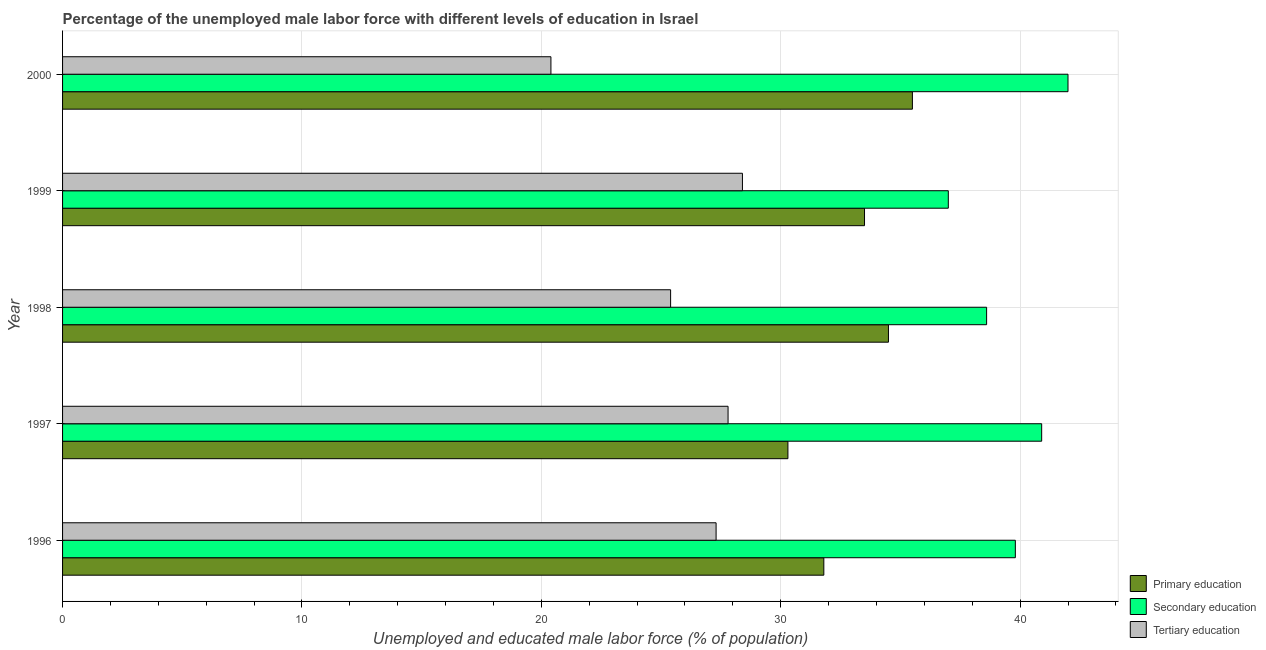How many different coloured bars are there?
Give a very brief answer. 3. Are the number of bars per tick equal to the number of legend labels?
Ensure brevity in your answer.  Yes. Are the number of bars on each tick of the Y-axis equal?
Your answer should be compact. Yes. What is the label of the 1st group of bars from the top?
Make the answer very short. 2000. What is the percentage of male labor force who received secondary education in 1999?
Make the answer very short. 37. Across all years, what is the maximum percentage of male labor force who received primary education?
Offer a terse response. 35.5. In which year was the percentage of male labor force who received secondary education maximum?
Give a very brief answer. 2000. In which year was the percentage of male labor force who received primary education minimum?
Your response must be concise. 1997. What is the total percentage of male labor force who received primary education in the graph?
Ensure brevity in your answer.  165.6. What is the difference between the percentage of male labor force who received primary education in 1998 and that in 1999?
Provide a short and direct response. 1. What is the difference between the percentage of male labor force who received primary education in 1997 and the percentage of male labor force who received tertiary education in 1999?
Offer a very short reply. 1.9. What is the average percentage of male labor force who received primary education per year?
Your answer should be very brief. 33.12. In how many years, is the percentage of male labor force who received secondary education greater than 8 %?
Give a very brief answer. 5. What is the ratio of the percentage of male labor force who received tertiary education in 1997 to that in 1998?
Your response must be concise. 1.09. Is the difference between the percentage of male labor force who received primary education in 1996 and 1998 greater than the difference between the percentage of male labor force who received tertiary education in 1996 and 1998?
Your answer should be compact. No. In how many years, is the percentage of male labor force who received secondary education greater than the average percentage of male labor force who received secondary education taken over all years?
Offer a terse response. 3. Is the sum of the percentage of male labor force who received secondary education in 1997 and 2000 greater than the maximum percentage of male labor force who received tertiary education across all years?
Provide a short and direct response. Yes. What does the 1st bar from the top in 1996 represents?
Provide a succinct answer. Tertiary education. What does the 3rd bar from the bottom in 1996 represents?
Offer a terse response. Tertiary education. Are all the bars in the graph horizontal?
Keep it short and to the point. Yes. How many years are there in the graph?
Your response must be concise. 5. Does the graph contain grids?
Your response must be concise. Yes. What is the title of the graph?
Provide a short and direct response. Percentage of the unemployed male labor force with different levels of education in Israel. Does "Capital account" appear as one of the legend labels in the graph?
Provide a succinct answer. No. What is the label or title of the X-axis?
Provide a short and direct response. Unemployed and educated male labor force (% of population). What is the label or title of the Y-axis?
Ensure brevity in your answer.  Year. What is the Unemployed and educated male labor force (% of population) of Primary education in 1996?
Make the answer very short. 31.8. What is the Unemployed and educated male labor force (% of population) of Secondary education in 1996?
Provide a succinct answer. 39.8. What is the Unemployed and educated male labor force (% of population) of Tertiary education in 1996?
Make the answer very short. 27.3. What is the Unemployed and educated male labor force (% of population) in Primary education in 1997?
Make the answer very short. 30.3. What is the Unemployed and educated male labor force (% of population) in Secondary education in 1997?
Make the answer very short. 40.9. What is the Unemployed and educated male labor force (% of population) in Tertiary education in 1997?
Provide a succinct answer. 27.8. What is the Unemployed and educated male labor force (% of population) of Primary education in 1998?
Provide a short and direct response. 34.5. What is the Unemployed and educated male labor force (% of population) of Secondary education in 1998?
Your answer should be compact. 38.6. What is the Unemployed and educated male labor force (% of population) in Tertiary education in 1998?
Your response must be concise. 25.4. What is the Unemployed and educated male labor force (% of population) in Primary education in 1999?
Offer a terse response. 33.5. What is the Unemployed and educated male labor force (% of population) in Tertiary education in 1999?
Provide a succinct answer. 28.4. What is the Unemployed and educated male labor force (% of population) in Primary education in 2000?
Make the answer very short. 35.5. What is the Unemployed and educated male labor force (% of population) of Tertiary education in 2000?
Provide a succinct answer. 20.4. Across all years, what is the maximum Unemployed and educated male labor force (% of population) of Primary education?
Give a very brief answer. 35.5. Across all years, what is the maximum Unemployed and educated male labor force (% of population) of Secondary education?
Provide a succinct answer. 42. Across all years, what is the maximum Unemployed and educated male labor force (% of population) in Tertiary education?
Offer a terse response. 28.4. Across all years, what is the minimum Unemployed and educated male labor force (% of population) in Primary education?
Give a very brief answer. 30.3. Across all years, what is the minimum Unemployed and educated male labor force (% of population) of Secondary education?
Offer a terse response. 37. Across all years, what is the minimum Unemployed and educated male labor force (% of population) in Tertiary education?
Provide a succinct answer. 20.4. What is the total Unemployed and educated male labor force (% of population) in Primary education in the graph?
Your answer should be very brief. 165.6. What is the total Unemployed and educated male labor force (% of population) of Secondary education in the graph?
Your answer should be very brief. 198.3. What is the total Unemployed and educated male labor force (% of population) in Tertiary education in the graph?
Provide a succinct answer. 129.3. What is the difference between the Unemployed and educated male labor force (% of population) in Tertiary education in 1996 and that in 1997?
Offer a terse response. -0.5. What is the difference between the Unemployed and educated male labor force (% of population) in Primary education in 1996 and that in 1998?
Your answer should be compact. -2.7. What is the difference between the Unemployed and educated male labor force (% of population) in Secondary education in 1996 and that in 1998?
Offer a very short reply. 1.2. What is the difference between the Unemployed and educated male labor force (% of population) of Primary education in 1996 and that in 1999?
Your response must be concise. -1.7. What is the difference between the Unemployed and educated male labor force (% of population) in Primary education in 1996 and that in 2000?
Ensure brevity in your answer.  -3.7. What is the difference between the Unemployed and educated male labor force (% of population) in Tertiary education in 1996 and that in 2000?
Provide a succinct answer. 6.9. What is the difference between the Unemployed and educated male labor force (% of population) in Primary education in 1997 and that in 1998?
Keep it short and to the point. -4.2. What is the difference between the Unemployed and educated male labor force (% of population) in Secondary education in 1997 and that in 1999?
Your response must be concise. 3.9. What is the difference between the Unemployed and educated male labor force (% of population) of Tertiary education in 1997 and that in 1999?
Provide a succinct answer. -0.6. What is the difference between the Unemployed and educated male labor force (% of population) of Secondary education in 1997 and that in 2000?
Your answer should be very brief. -1.1. What is the difference between the Unemployed and educated male labor force (% of population) of Tertiary education in 1997 and that in 2000?
Your answer should be very brief. 7.4. What is the difference between the Unemployed and educated male labor force (% of population) in Primary education in 1998 and that in 2000?
Provide a succinct answer. -1. What is the difference between the Unemployed and educated male labor force (% of population) of Primary education in 1999 and that in 2000?
Make the answer very short. -2. What is the difference between the Unemployed and educated male labor force (% of population) of Tertiary education in 1999 and that in 2000?
Make the answer very short. 8. What is the difference between the Unemployed and educated male labor force (% of population) in Primary education in 1996 and the Unemployed and educated male labor force (% of population) in Secondary education in 1997?
Your answer should be compact. -9.1. What is the difference between the Unemployed and educated male labor force (% of population) of Primary education in 1996 and the Unemployed and educated male labor force (% of population) of Tertiary education in 1997?
Your answer should be compact. 4. What is the difference between the Unemployed and educated male labor force (% of population) in Primary education in 1996 and the Unemployed and educated male labor force (% of population) in Secondary education in 1998?
Provide a short and direct response. -6.8. What is the difference between the Unemployed and educated male labor force (% of population) of Primary education in 1996 and the Unemployed and educated male labor force (% of population) of Tertiary education in 1998?
Your response must be concise. 6.4. What is the difference between the Unemployed and educated male labor force (% of population) in Primary education in 1996 and the Unemployed and educated male labor force (% of population) in Tertiary education in 1999?
Your answer should be very brief. 3.4. What is the difference between the Unemployed and educated male labor force (% of population) in Secondary education in 1996 and the Unemployed and educated male labor force (% of population) in Tertiary education in 1999?
Your answer should be compact. 11.4. What is the difference between the Unemployed and educated male labor force (% of population) of Primary education in 1996 and the Unemployed and educated male labor force (% of population) of Secondary education in 2000?
Offer a very short reply. -10.2. What is the difference between the Unemployed and educated male labor force (% of population) in Secondary education in 1996 and the Unemployed and educated male labor force (% of population) in Tertiary education in 2000?
Offer a terse response. 19.4. What is the difference between the Unemployed and educated male labor force (% of population) in Primary education in 1997 and the Unemployed and educated male labor force (% of population) in Secondary education in 1998?
Ensure brevity in your answer.  -8.3. What is the difference between the Unemployed and educated male labor force (% of population) in Primary education in 1997 and the Unemployed and educated male labor force (% of population) in Tertiary education in 1998?
Offer a very short reply. 4.9. What is the difference between the Unemployed and educated male labor force (% of population) in Primary education in 1997 and the Unemployed and educated male labor force (% of population) in Tertiary education in 2000?
Your answer should be very brief. 9.9. What is the difference between the Unemployed and educated male labor force (% of population) in Secondary education in 1997 and the Unemployed and educated male labor force (% of population) in Tertiary education in 2000?
Offer a very short reply. 20.5. What is the difference between the Unemployed and educated male labor force (% of population) in Primary education in 1998 and the Unemployed and educated male labor force (% of population) in Tertiary education in 1999?
Ensure brevity in your answer.  6.1. What is the difference between the Unemployed and educated male labor force (% of population) of Secondary education in 1998 and the Unemployed and educated male labor force (% of population) of Tertiary education in 2000?
Ensure brevity in your answer.  18.2. What is the difference between the Unemployed and educated male labor force (% of population) of Primary education in 1999 and the Unemployed and educated male labor force (% of population) of Tertiary education in 2000?
Give a very brief answer. 13.1. What is the difference between the Unemployed and educated male labor force (% of population) of Secondary education in 1999 and the Unemployed and educated male labor force (% of population) of Tertiary education in 2000?
Your answer should be compact. 16.6. What is the average Unemployed and educated male labor force (% of population) of Primary education per year?
Give a very brief answer. 33.12. What is the average Unemployed and educated male labor force (% of population) of Secondary education per year?
Keep it short and to the point. 39.66. What is the average Unemployed and educated male labor force (% of population) in Tertiary education per year?
Make the answer very short. 25.86. In the year 1996, what is the difference between the Unemployed and educated male labor force (% of population) of Primary education and Unemployed and educated male labor force (% of population) of Secondary education?
Ensure brevity in your answer.  -8. In the year 1997, what is the difference between the Unemployed and educated male labor force (% of population) in Primary education and Unemployed and educated male labor force (% of population) in Secondary education?
Your answer should be compact. -10.6. In the year 1997, what is the difference between the Unemployed and educated male labor force (% of population) in Secondary education and Unemployed and educated male labor force (% of population) in Tertiary education?
Keep it short and to the point. 13.1. In the year 1998, what is the difference between the Unemployed and educated male labor force (% of population) of Primary education and Unemployed and educated male labor force (% of population) of Secondary education?
Your response must be concise. -4.1. In the year 1999, what is the difference between the Unemployed and educated male labor force (% of population) in Primary education and Unemployed and educated male labor force (% of population) in Tertiary education?
Your response must be concise. 5.1. In the year 2000, what is the difference between the Unemployed and educated male labor force (% of population) of Primary education and Unemployed and educated male labor force (% of population) of Secondary education?
Offer a very short reply. -6.5. In the year 2000, what is the difference between the Unemployed and educated male labor force (% of population) in Primary education and Unemployed and educated male labor force (% of population) in Tertiary education?
Provide a succinct answer. 15.1. In the year 2000, what is the difference between the Unemployed and educated male labor force (% of population) in Secondary education and Unemployed and educated male labor force (% of population) in Tertiary education?
Offer a terse response. 21.6. What is the ratio of the Unemployed and educated male labor force (% of population) of Primary education in 1996 to that in 1997?
Make the answer very short. 1.05. What is the ratio of the Unemployed and educated male labor force (% of population) in Secondary education in 1996 to that in 1997?
Offer a terse response. 0.97. What is the ratio of the Unemployed and educated male labor force (% of population) of Tertiary education in 1996 to that in 1997?
Offer a very short reply. 0.98. What is the ratio of the Unemployed and educated male labor force (% of population) in Primary education in 1996 to that in 1998?
Keep it short and to the point. 0.92. What is the ratio of the Unemployed and educated male labor force (% of population) of Secondary education in 1996 to that in 1998?
Your response must be concise. 1.03. What is the ratio of the Unemployed and educated male labor force (% of population) of Tertiary education in 1996 to that in 1998?
Offer a very short reply. 1.07. What is the ratio of the Unemployed and educated male labor force (% of population) of Primary education in 1996 to that in 1999?
Offer a terse response. 0.95. What is the ratio of the Unemployed and educated male labor force (% of population) of Secondary education in 1996 to that in 1999?
Your response must be concise. 1.08. What is the ratio of the Unemployed and educated male labor force (% of population) of Tertiary education in 1996 to that in 1999?
Your response must be concise. 0.96. What is the ratio of the Unemployed and educated male labor force (% of population) in Primary education in 1996 to that in 2000?
Make the answer very short. 0.9. What is the ratio of the Unemployed and educated male labor force (% of population) of Secondary education in 1996 to that in 2000?
Provide a short and direct response. 0.95. What is the ratio of the Unemployed and educated male labor force (% of population) in Tertiary education in 1996 to that in 2000?
Your answer should be compact. 1.34. What is the ratio of the Unemployed and educated male labor force (% of population) in Primary education in 1997 to that in 1998?
Keep it short and to the point. 0.88. What is the ratio of the Unemployed and educated male labor force (% of population) of Secondary education in 1997 to that in 1998?
Your answer should be very brief. 1.06. What is the ratio of the Unemployed and educated male labor force (% of population) of Tertiary education in 1997 to that in 1998?
Offer a very short reply. 1.09. What is the ratio of the Unemployed and educated male labor force (% of population) in Primary education in 1997 to that in 1999?
Your response must be concise. 0.9. What is the ratio of the Unemployed and educated male labor force (% of population) of Secondary education in 1997 to that in 1999?
Ensure brevity in your answer.  1.11. What is the ratio of the Unemployed and educated male labor force (% of population) in Tertiary education in 1997 to that in 1999?
Your response must be concise. 0.98. What is the ratio of the Unemployed and educated male labor force (% of population) of Primary education in 1997 to that in 2000?
Give a very brief answer. 0.85. What is the ratio of the Unemployed and educated male labor force (% of population) of Secondary education in 1997 to that in 2000?
Offer a very short reply. 0.97. What is the ratio of the Unemployed and educated male labor force (% of population) in Tertiary education in 1997 to that in 2000?
Provide a short and direct response. 1.36. What is the ratio of the Unemployed and educated male labor force (% of population) in Primary education in 1998 to that in 1999?
Offer a terse response. 1.03. What is the ratio of the Unemployed and educated male labor force (% of population) of Secondary education in 1998 to that in 1999?
Your response must be concise. 1.04. What is the ratio of the Unemployed and educated male labor force (% of population) of Tertiary education in 1998 to that in 1999?
Offer a very short reply. 0.89. What is the ratio of the Unemployed and educated male labor force (% of population) in Primary education in 1998 to that in 2000?
Give a very brief answer. 0.97. What is the ratio of the Unemployed and educated male labor force (% of population) in Secondary education in 1998 to that in 2000?
Make the answer very short. 0.92. What is the ratio of the Unemployed and educated male labor force (% of population) of Tertiary education in 1998 to that in 2000?
Provide a succinct answer. 1.25. What is the ratio of the Unemployed and educated male labor force (% of population) in Primary education in 1999 to that in 2000?
Offer a very short reply. 0.94. What is the ratio of the Unemployed and educated male labor force (% of population) of Secondary education in 1999 to that in 2000?
Provide a succinct answer. 0.88. What is the ratio of the Unemployed and educated male labor force (% of population) of Tertiary education in 1999 to that in 2000?
Give a very brief answer. 1.39. What is the difference between the highest and the lowest Unemployed and educated male labor force (% of population) of Primary education?
Provide a succinct answer. 5.2. What is the difference between the highest and the lowest Unemployed and educated male labor force (% of population) of Secondary education?
Keep it short and to the point. 5. 